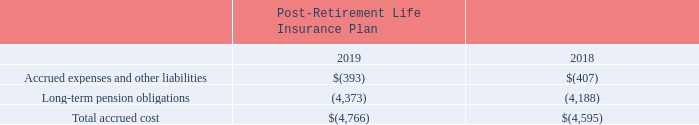NOTES TO CONSOLIDATED FINANCIAL STATEMENTS (in thousands, except for share and per share data)
The components of the accrued cost of the post-retirement life insurance plan are classified in the following lines in the Consolidated Balance Sheets at December 31:
What was the Accrued expenses and other liabilities in 2018?
Answer scale should be: thousand. (407). What was the total accrued cost in 2019?
Answer scale should be: thousand. (4,766). What were the Long-term pension obligations in 2018?
Answer scale should be: thousand. (4,188). What was the change in the Accrued expenses and other liabilities between 2018 and 2019?
Answer scale should be: thousand. -393-(-407)
Answer: 14. What was the change in the Long-term pension obligations between 2018 and 2019?
Answer scale should be: thousand. -4,373-(-4,188)
Answer: -185. What was the percentage change in the total accrued cost between 2018 and 2019?
Answer scale should be: percent. (-4,766-(-4,595))/-4,595
Answer: 3.72. 